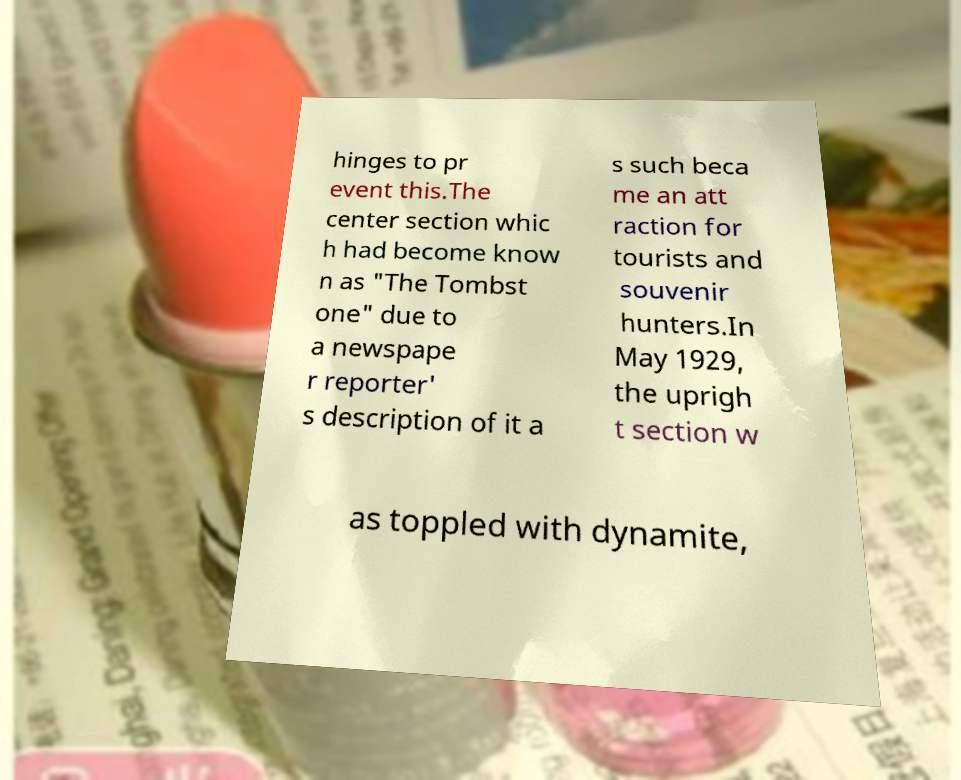What messages or text are displayed in this image? I need them in a readable, typed format. hinges to pr event this.The center section whic h had become know n as "The Tombst one" due to a newspape r reporter' s description of it a s such beca me an att raction for tourists and souvenir hunters.In May 1929, the uprigh t section w as toppled with dynamite, 